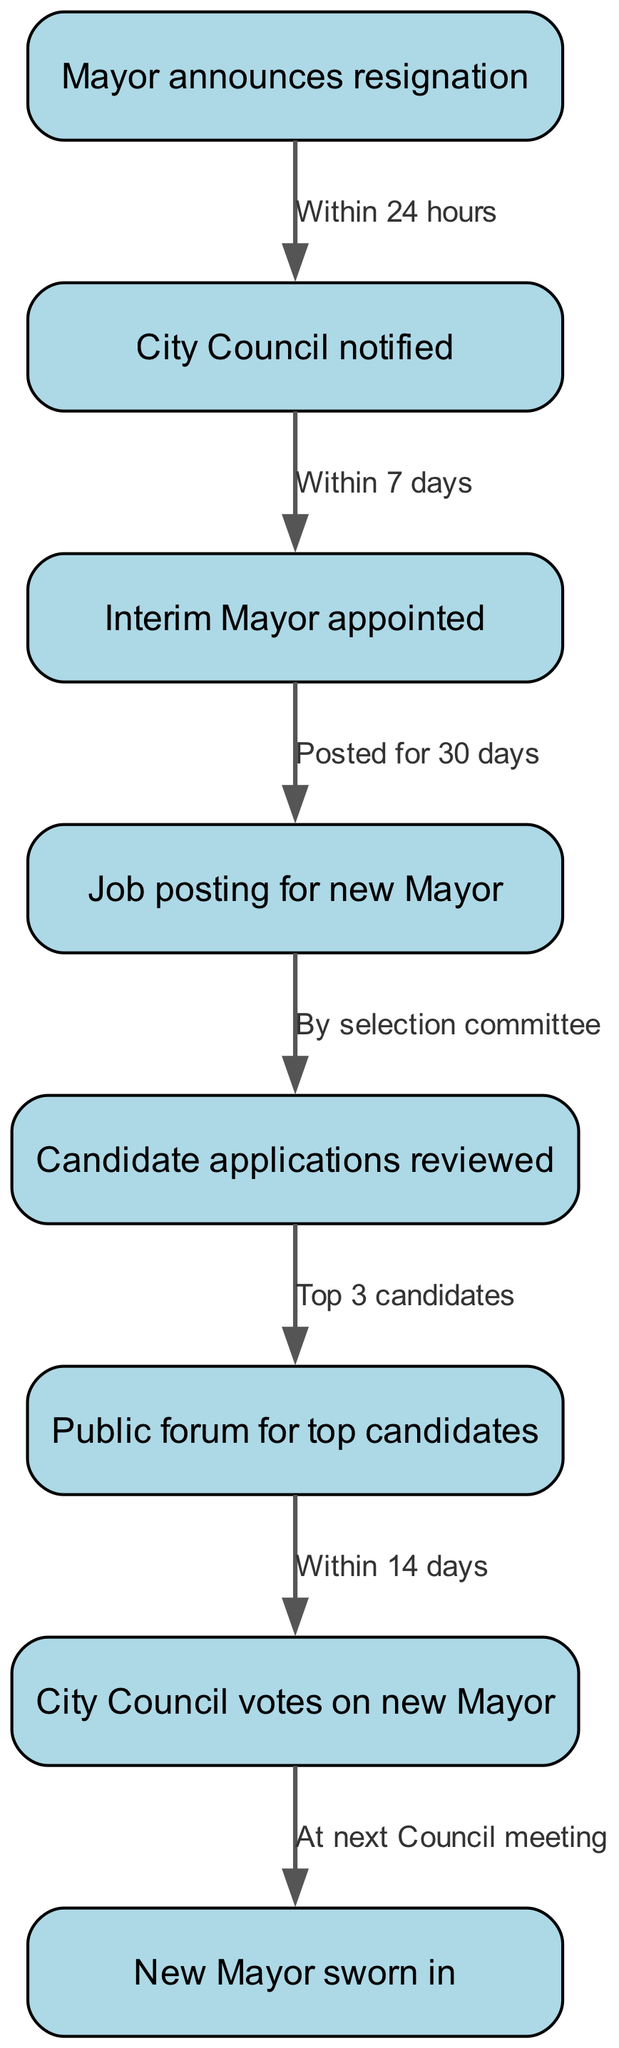What is the first step in the flow chart? The first step is represented by the node labeled "Mayor announces resignation." This is the starting point of the transition process.
Answer: Mayor announces resignation How many nodes are present in the diagram? By counting all the distinct steps (nodes) outlined in the flow chart, we find that there are a total of 8 nodes.
Answer: 8 What is the time frame for notifying the City Council? The edge from "Mayor announces resignation" to "City Council notified" specifies that this notification must occur "Within 24 hours."
Answer: Within 24 hours What is the next step after appointing an Interim Mayor? The flow chart indicates that after the Interim Mayor is appointed, the next step is to post a job listing for the new Mayor. This is shown as the direct subsequent node.
Answer: Job posting for new Mayor How are candidate applications reviewed? The flow chart mentions that candidate applications are reviewed "By selection committee," which is the method specified for this process.
Answer: By selection committee What happens after the public forum for top candidates? Following the public forum, the next action taken is for the City Council to vote on the new Mayor. This sequence clearly connects the public forum and the voting phase.
Answer: City Council votes on new Mayor How long after the City Council votes does the new Mayor get sworn in? According to the diagram, the swearing-in of the new Mayor occurs "At next Council meeting," which implies directly after the voting action is completed.
Answer: At next Council meeting What is the time frame for conducting the public forum for top candidates? The edge from the node representing public forum to City Council voting indicates that this must be completed "Within 14 days." This timeframe is crucial for the election process to move forward smoothly.
Answer: Within 14 days What is the last step documented in the flow chart? The final node in the flow chart outlines the last action as "New Mayor sworn in," indicating the completion of the leadership transition process.
Answer: New Mayor sworn in 